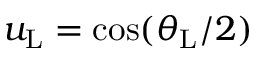Convert formula to latex. <formula><loc_0><loc_0><loc_500><loc_500>u _ { L } = \cos ( \theta _ { L } / 2 )</formula> 